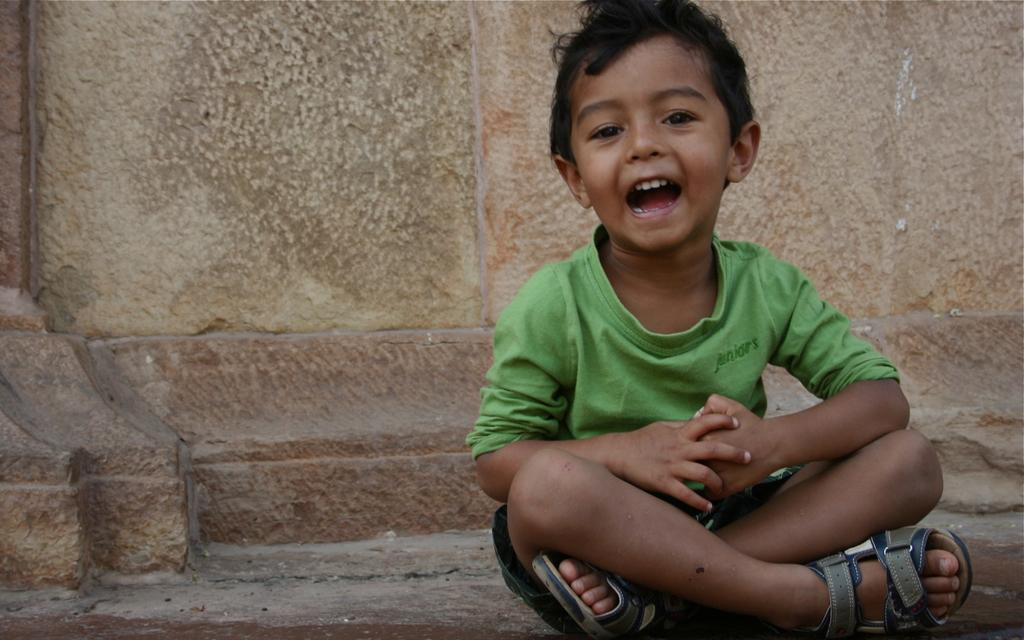What is the main subject of the image? There is a boy sitting in the image. What can be seen in the background of the image? There is a wall in the background of the image. What type of thumb is the boy holding up in the image? There is no thumb visible in the image; the boy is simply sitting. 